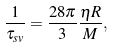<formula> <loc_0><loc_0><loc_500><loc_500>\frac { 1 } { \tau _ { s v } } = \frac { 2 8 \pi } { 3 } \frac { \eta R } { M } ,</formula> 